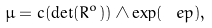Convert formula to latex. <formula><loc_0><loc_0><loc_500><loc_500>\mu = c ( \det ( R ^ { o } ) ) \wedge \exp ( \ e p ) ,</formula> 